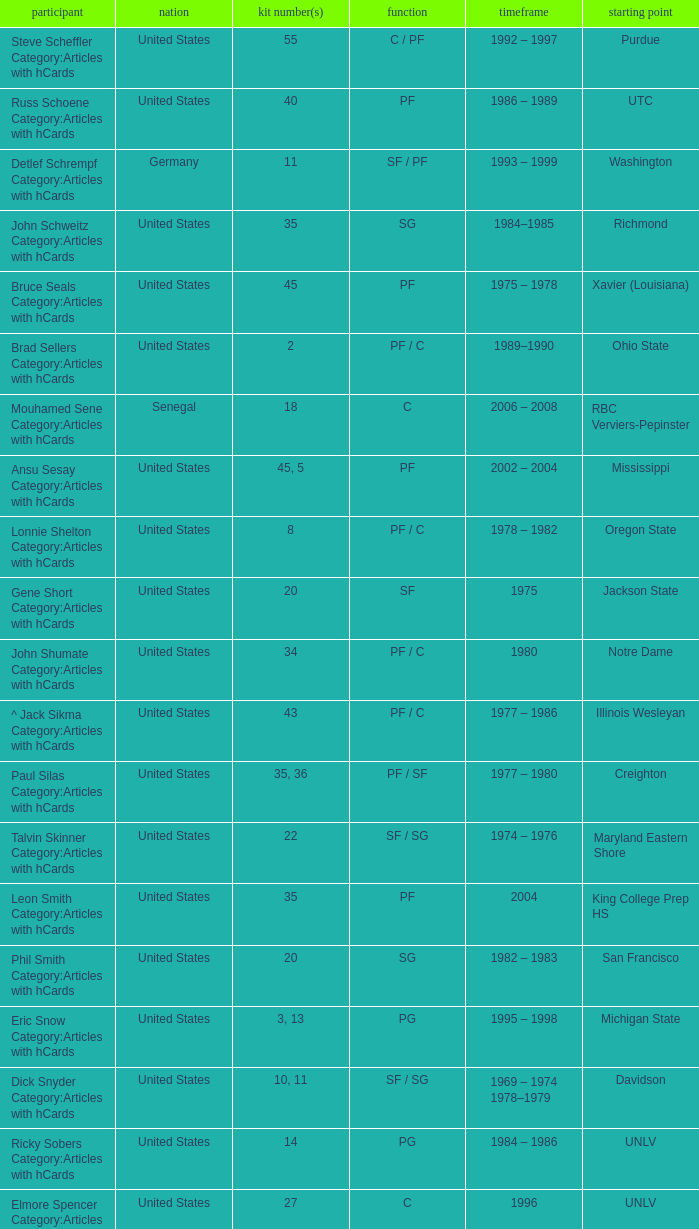What position does the player with jersey number 22 play? SF / SG. 